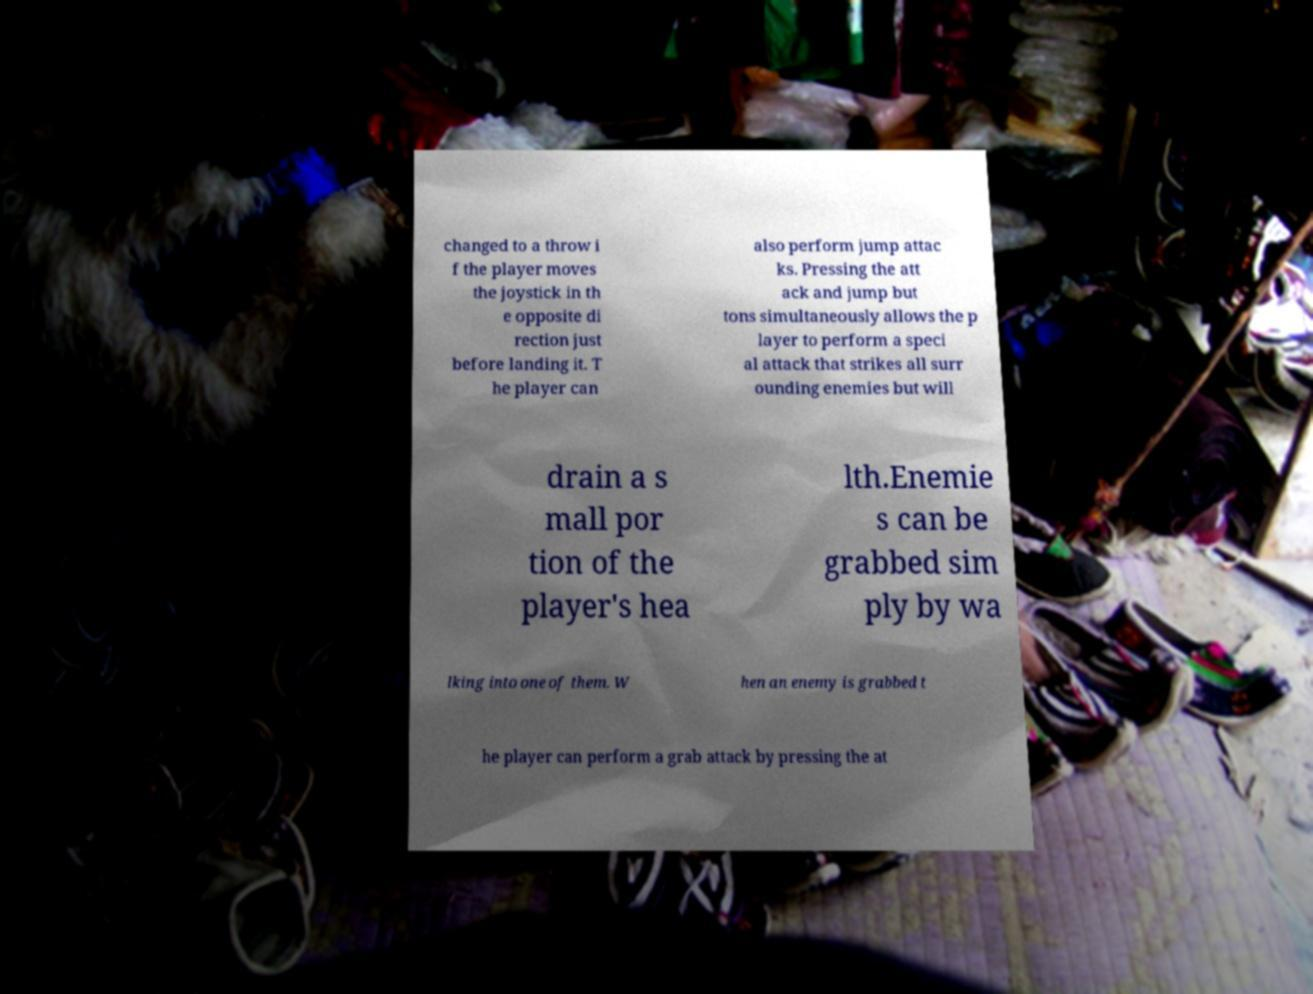Can you read and provide the text displayed in the image?This photo seems to have some interesting text. Can you extract and type it out for me? changed to a throw i f the player moves the joystick in th e opposite di rection just before landing it. T he player can also perform jump attac ks. Pressing the att ack and jump but tons simultaneously allows the p layer to perform a speci al attack that strikes all surr ounding enemies but will drain a s mall por tion of the player's hea lth.Enemie s can be grabbed sim ply by wa lking into one of them. W hen an enemy is grabbed t he player can perform a grab attack by pressing the at 